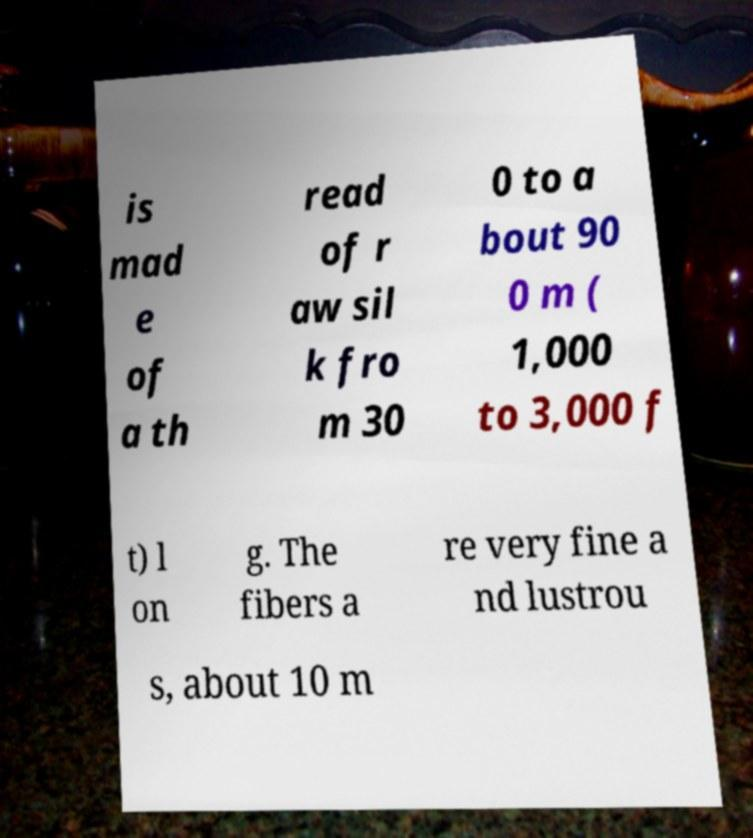Can you accurately transcribe the text from the provided image for me? is mad e of a th read of r aw sil k fro m 30 0 to a bout 90 0 m ( 1,000 to 3,000 f t) l on g. The fibers a re very fine a nd lustrou s, about 10 m 